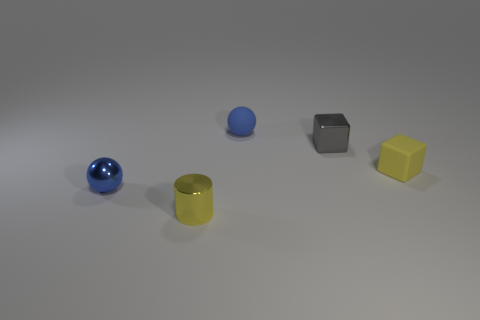There is a blue ball that is in front of the blue ball on the right side of the yellow thing left of the metallic cube; what is its size?
Provide a succinct answer. Small. What shape is the object on the left side of the yellow shiny object to the left of the matte thing on the right side of the gray object?
Offer a terse response. Sphere. The yellow thing to the right of the small cylinder has what shape?
Ensure brevity in your answer.  Cube. Is the material of the small gray thing the same as the blue sphere in front of the gray block?
Your answer should be very brief. Yes. How many other things are there of the same shape as the tiny yellow metallic object?
Make the answer very short. 0. There is a cylinder; is its color the same as the ball on the left side of the small yellow metallic cylinder?
Keep it short and to the point. No. There is a rubber thing that is in front of the rubber object that is behind the small gray metallic object; what is its shape?
Offer a very short reply. Cube. There is a metallic thing that is the same color as the small rubber sphere; what size is it?
Keep it short and to the point. Small. Is the shape of the small yellow thing that is in front of the small yellow rubber thing the same as  the yellow matte thing?
Give a very brief answer. No. Is the number of tiny yellow objects that are on the left side of the yellow matte block greater than the number of tiny yellow cylinders behind the blue metallic object?
Ensure brevity in your answer.  Yes. 